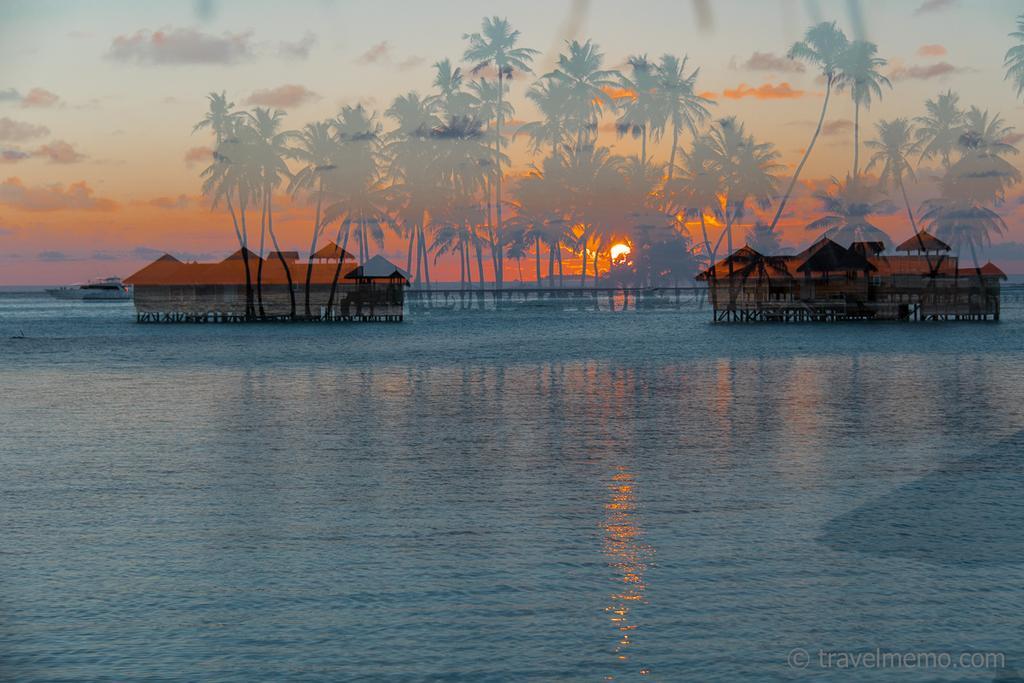In one or two sentences, can you explain what this image depicts? In this picture we can see water, houses and trees. In the background of the image we can see boat and sky with clouds. 